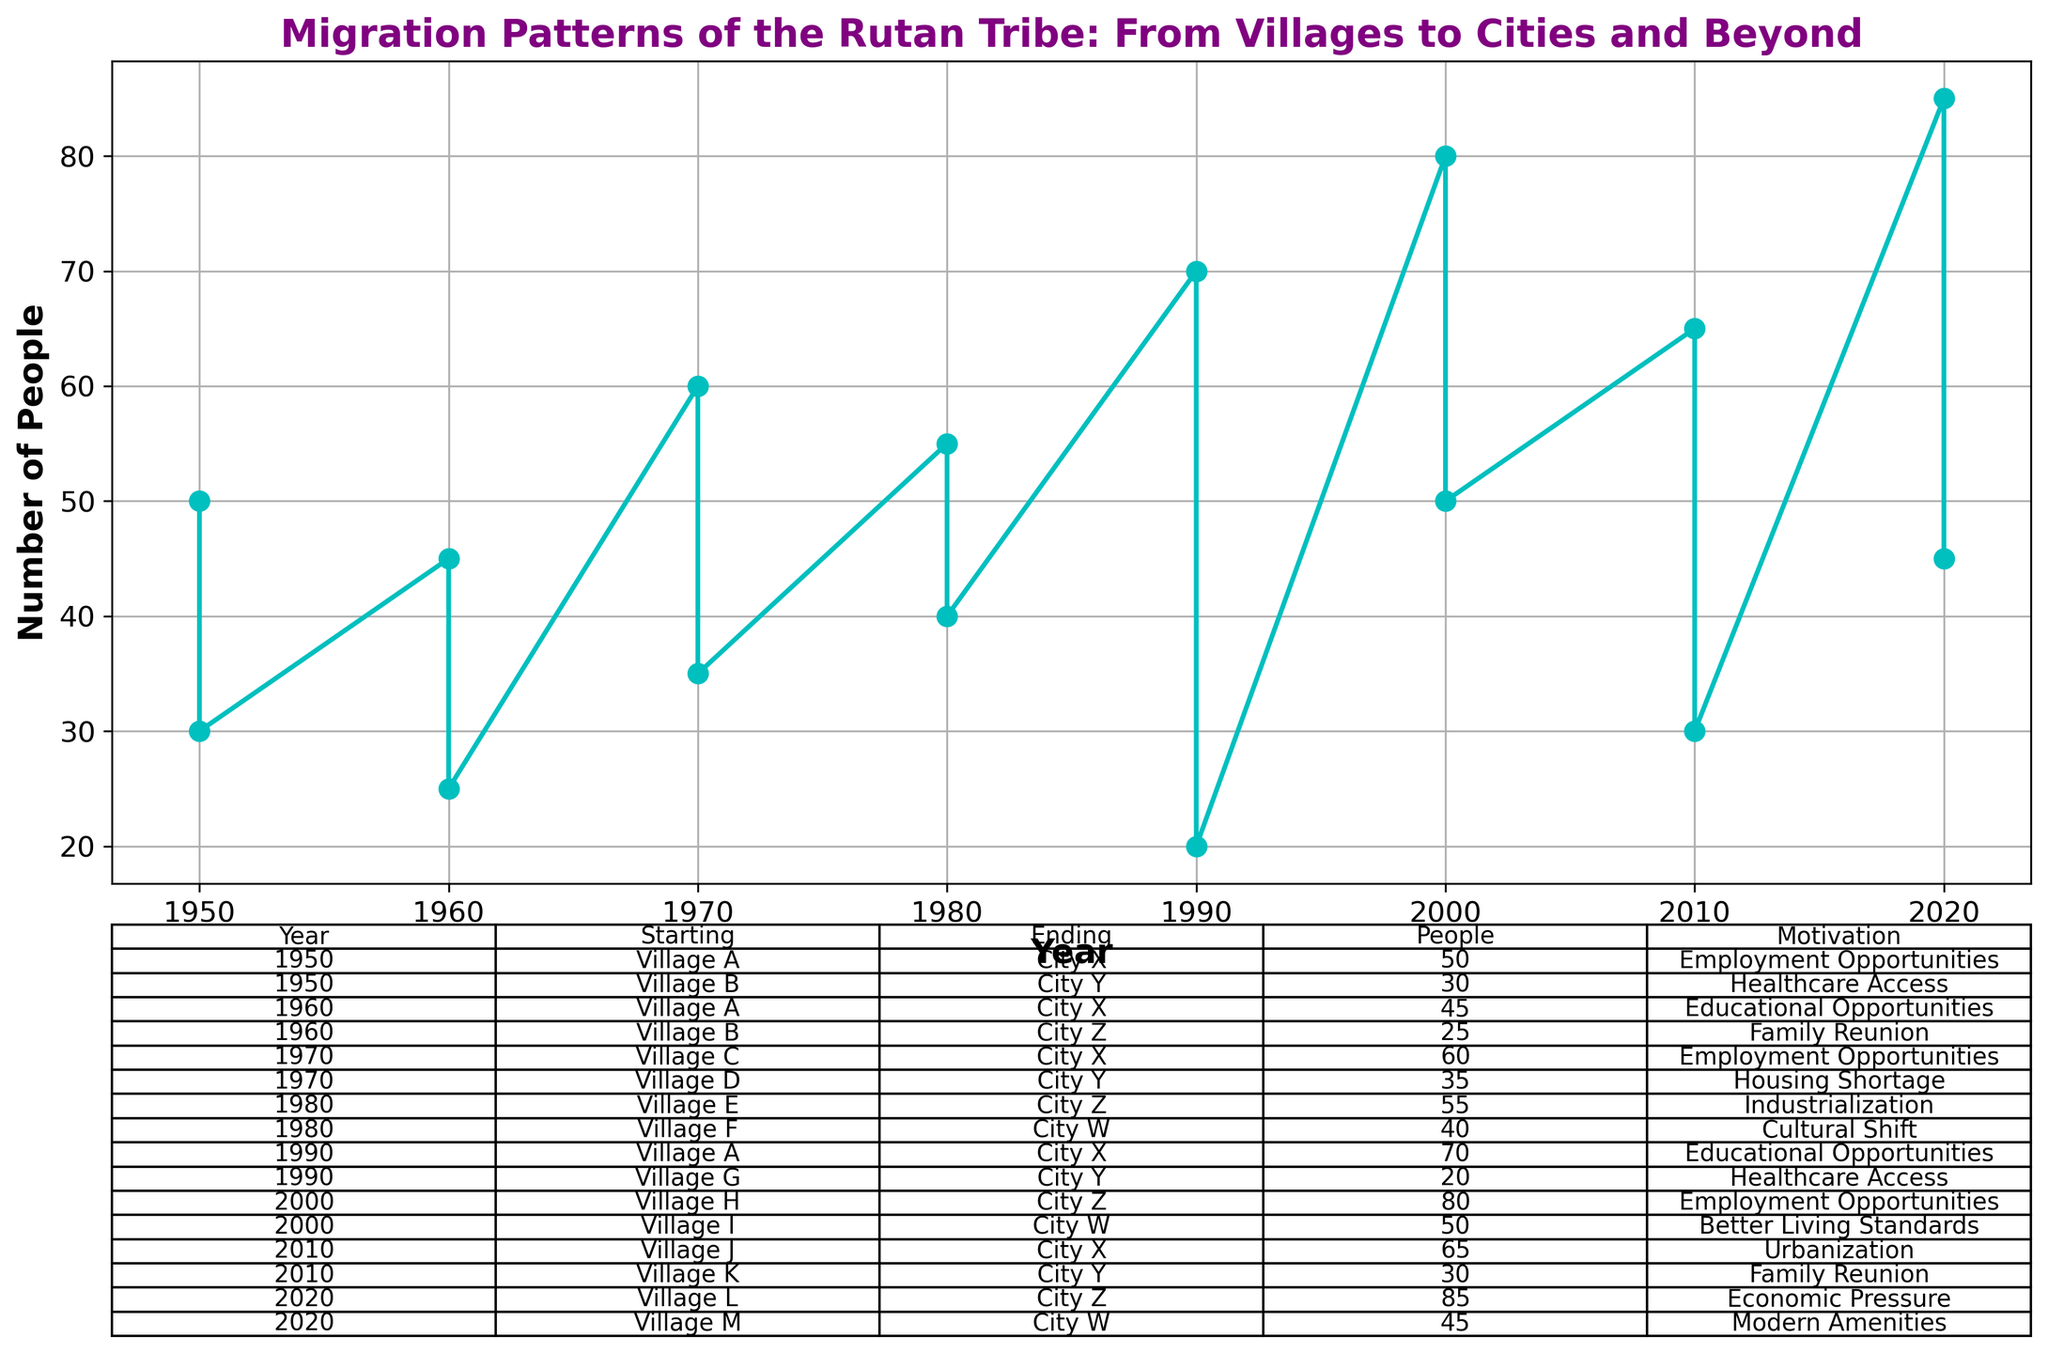How many people migrated from Village A to City X in 1950 and 1960 combined? The figure shows that in 1950, 50 people migrated from Village A to City X, and in 1960, 45 people did the same. Adding these two values together, 50 + 45 = 95.
Answer: 95 Which year had the highest number of people migrating from villages to cities, and how many people migrated that year? By examining the figure, 2020 had the highest number of people migrating. Combining the data for 2020, 85 + 45 = 130 people migrated.
Answer: 2020, 130 In which year did the migration due to Educational Opportunities from Village A to City X occur and how many people were involved? By looking at the table and plot, the migration for educational opportunities is seen twice for Village A to City X, occurring in 1960 with 45 people and again in 1990 with 70 people.
Answer: 1960: 45, 1990: 70 Which village to city migration had the lowest number of people in the figure, and how many people were involved? The figure shows that in 1990, the migration from Village G to City Y involved 20 people, which is the lowest number in the given data.
Answer: Village G to City Y, 20 Compare the number of people migrating from Village H to City Z in 2000 with the number of people migrating from Village K to City Y in 2010. Which was higher and by how much? In 2000, 80 people migrated from Village H to City Z, while in 2010, 30 people migrated from Village K to City Y. The difference is 80 - 30 = 50, so Village H to City Z had 50 more people.
Answer: Village H to City Z, by 50 What is the sum of the number of people who migrated for Employment Opportunities and for Healthcare Access? From the table, employing opportunity migrations are 50 (1950), 60 (1970), 80 (2000), and 85 (2020), summing to 275. Healthcare access migrations are 30 (1950) and 20 (1990), summing to 50. So, the total is 275 + 50 = 325.
Answer: 325 Which migrations had the same number of people (40), and what were the motivations for each? The figure shows that the migration from Village F to City W in 1980 involved 40 people (Cultural Shift), and from Village M to City W in 2020, 45 people migrated (Modern Amenities). The correct migration sharing 40 people are from Village I to City W in 2000 for better living standards.
Answer: Better Living Standards How many years after 1950 did the first migration due to Modern Amenities occur, and which villages were involved? According to the figure, the first migration due to Modern Amenities happened in 2020. Subtracting 1950 from 2020, it takes 70 years, and it involved Village M to City W.
Answer: 70 years, Village M to City W Between 1950 and 2010, which city had the highest inflow of migrants in total? Assessing the data, City X has the following number of migrants: 50 (1950), 45 (1960), 60 (1970), 70 (1990), and 65 (2010), summing it up to 50 + 45 + 60 + 70 + 65 = 290.
Answer: City X 